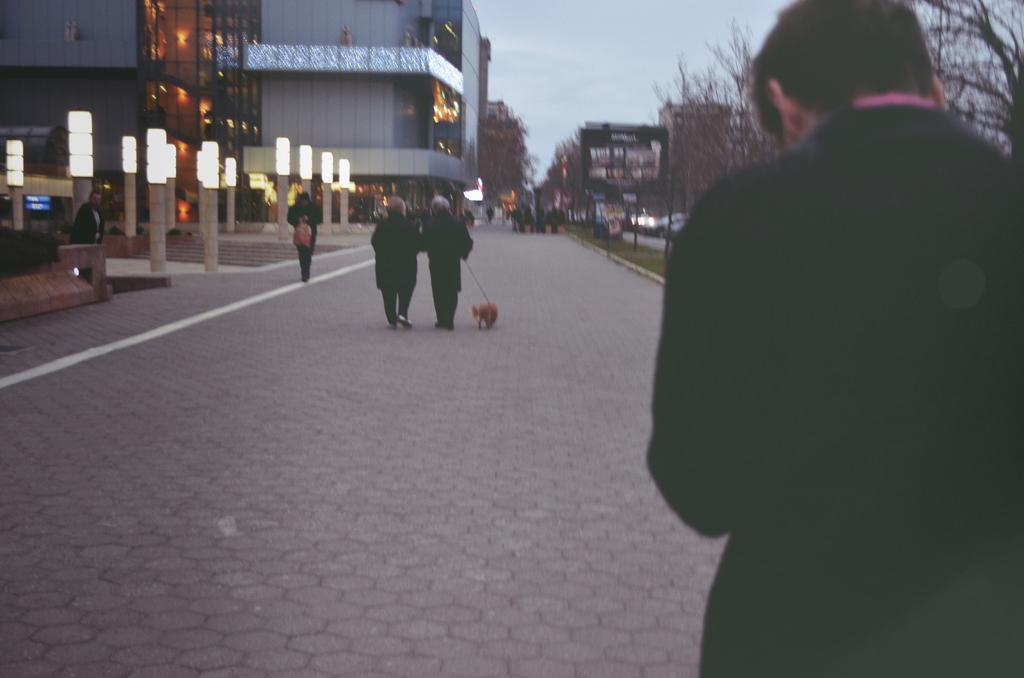What is located on the right side of the image? There is a man on the right side of the image. What is the man wearing? The man is wearing a black coat. What is happening in the middle of the image? There are two people walking in the middle of the image, and they are holding a dog. What can be seen on the left side of the image? There are lights and a building on the left side of the image. What type of coal is being used by the man in the image? There is no coal present in the image; the man is wearing a black coat. Who is the father of the two people walking in the image? There is no information about the relationship between the people in the image, so it cannot be determined who their father is. 